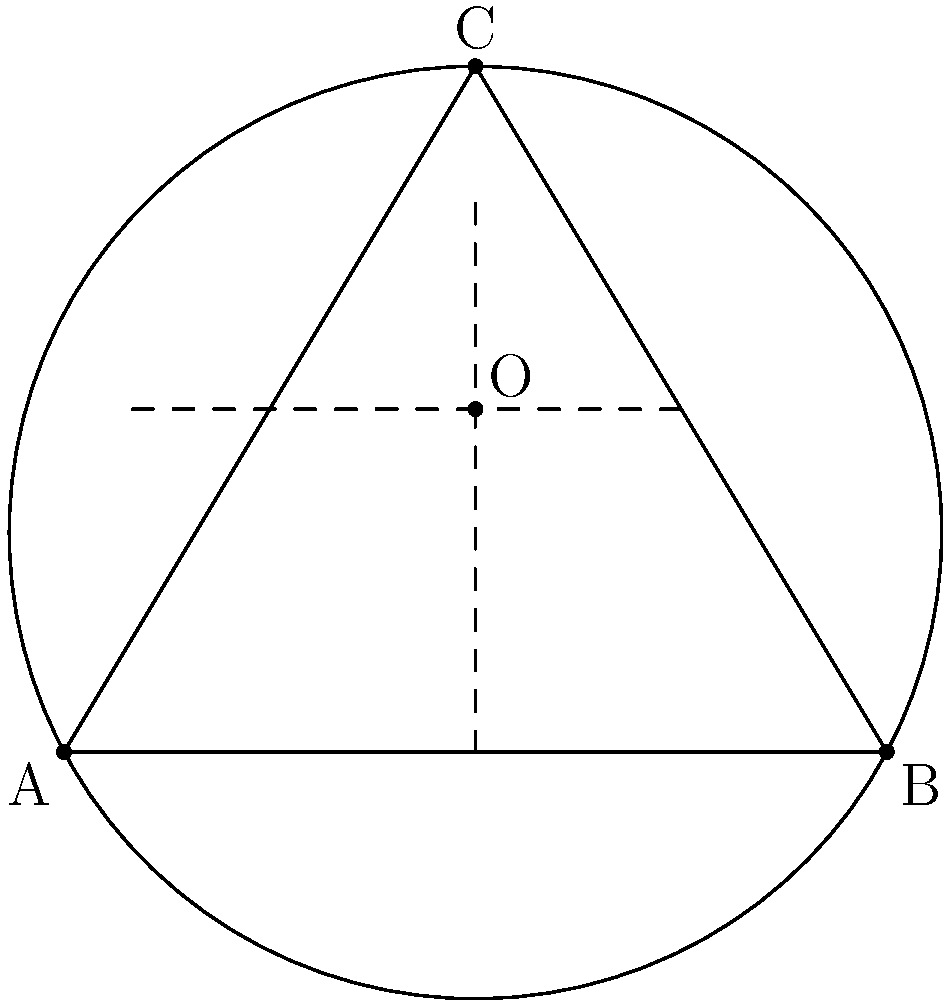As a fellow YouTuber, you're creating content on geometry for your channel. In your latest video, you want to demonstrate how to find the center of a circle given three points on its circumference. Given points A(0,0), B(6,0), and C(3,5) on a circle, how would you determine the coordinates of the circle's center? To find the center of a circle given three points on its circumference, we can use the following steps:

1) The center of the circle is equidistant from all points on the circumference. Therefore, it lies on the perpendicular bisector of any chord of the circle.

2) We can choose any two chords, find their perpendicular bisectors, and the intersection of these bisectors will be the center of the circle.

3) Let's choose chords AB and BC:

   For AB:
   - Midpoint: $M_1 = (\frac{0+6}{2}, \frac{0+0}{2}) = (3,0)$
   - Slope of AB: $m_{AB} = \frac{0-0}{6-0} = 0$
   - Slope of perpendicular bisector: $m_1 = -\frac{1}{m_{AB}} = \text{undefined (vertical line)}$
   - Equation of perpendicular bisector: $x = 3$

   For BC:
   - Midpoint: $M_2 = (\frac{6+3}{2}, \frac{0+5}{2}) = (4.5, 2.5)$
   - Slope of BC: $m_{BC} = \frac{5-0}{3-6} = -\frac{5}{3}$
   - Slope of perpendicular bisector: $m_2 = -\frac{1}{m_{BC}} = \frac{3}{5}$
   - Equation of perpendicular bisector: $y - 2.5 = \frac{3}{5}(x - 4.5)$

4) The center (x, y) is at the intersection of these two lines:
   $x = 3$
   $y - 2.5 = \frac{3}{5}(3 - 4.5) = -0.9$

5) Solving this system:
   $x = 3$
   $y = 2.5 - 0.9 = 1.6$

Therefore, the center of the circle is at (3, 1.6).
Answer: (3, 1.6) 